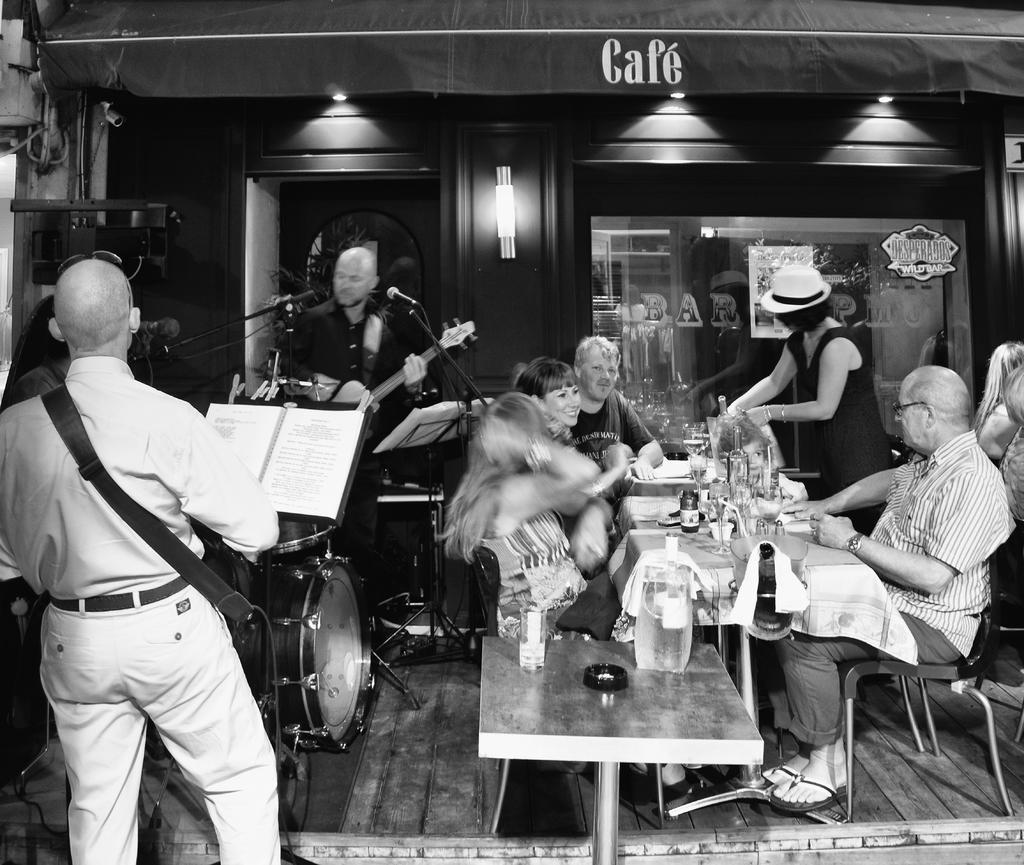Please provide a concise description of this image. This picture describes about group of people some are seated on the chair and some are standing, left side of the given image few people are playing musical instruments in front of microphone, 